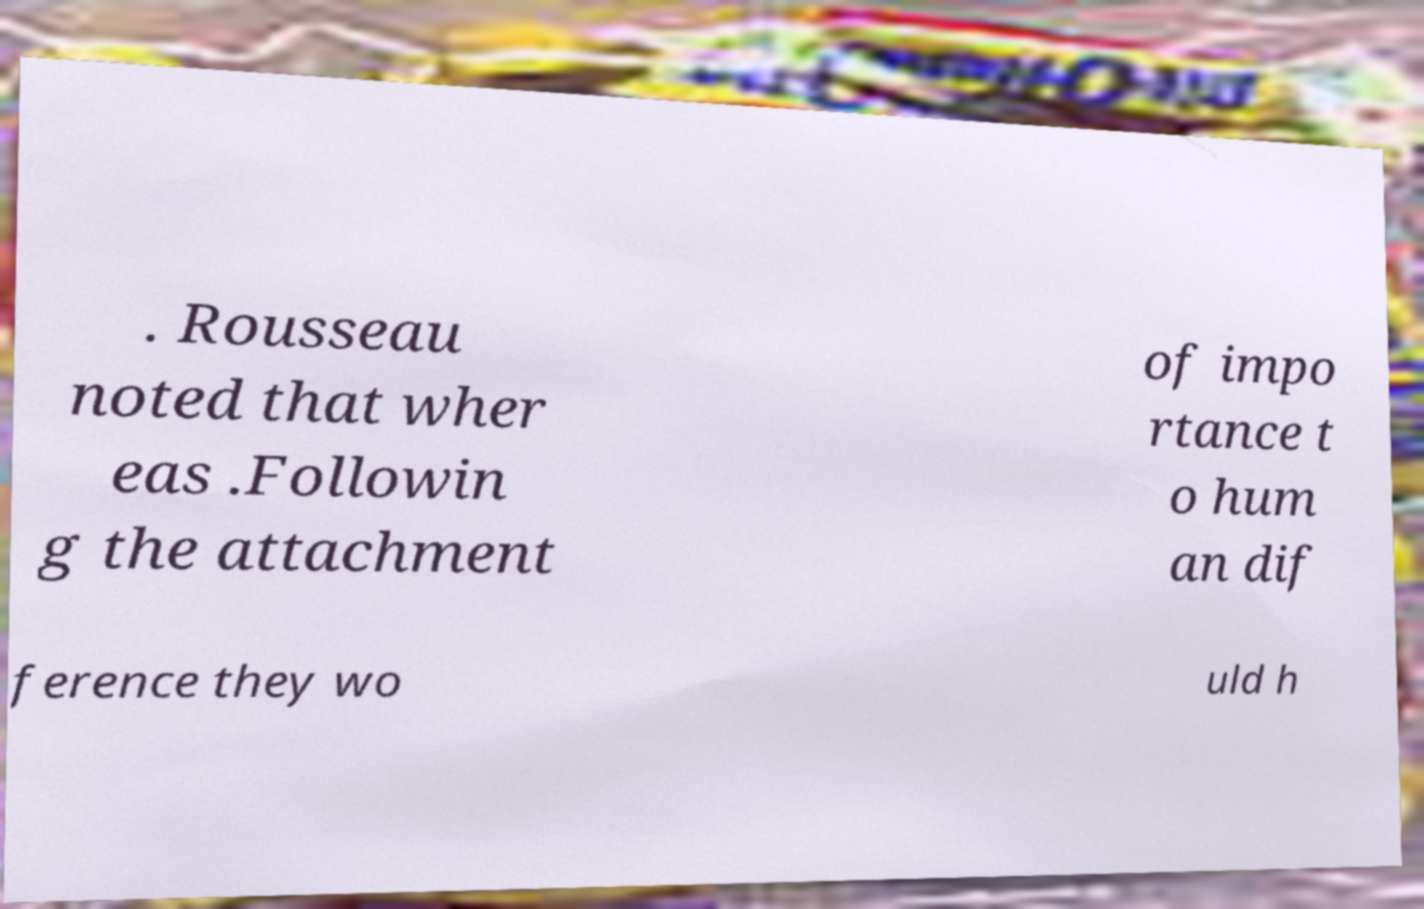Could you extract and type out the text from this image? . Rousseau noted that wher eas .Followin g the attachment of impo rtance t o hum an dif ference they wo uld h 